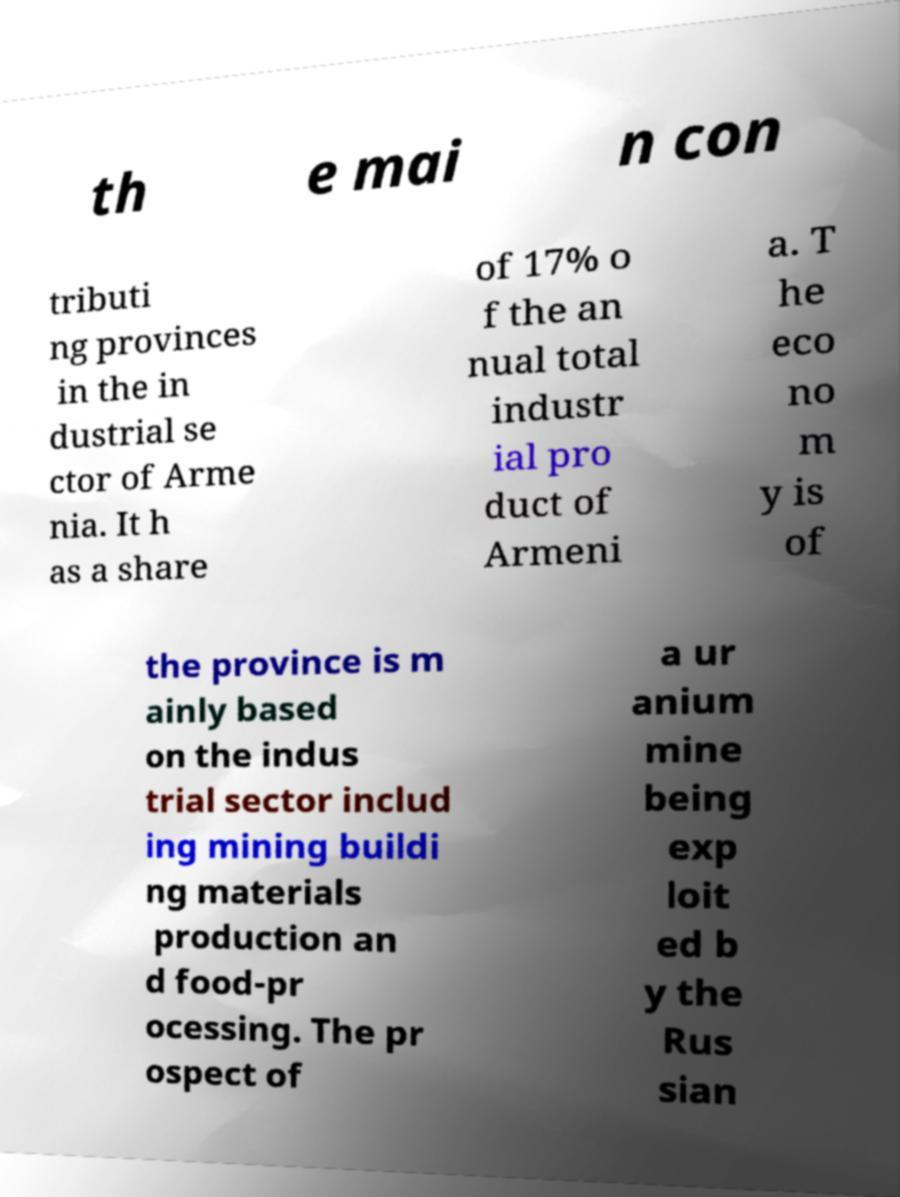Can you read and provide the text displayed in the image?This photo seems to have some interesting text. Can you extract and type it out for me? th e mai n con tributi ng provinces in the in dustrial se ctor of Arme nia. It h as a share of 17% o f the an nual total industr ial pro duct of Armeni a. T he eco no m y is of the province is m ainly based on the indus trial sector includ ing mining buildi ng materials production an d food-pr ocessing. The pr ospect of a ur anium mine being exp loit ed b y the Rus sian 